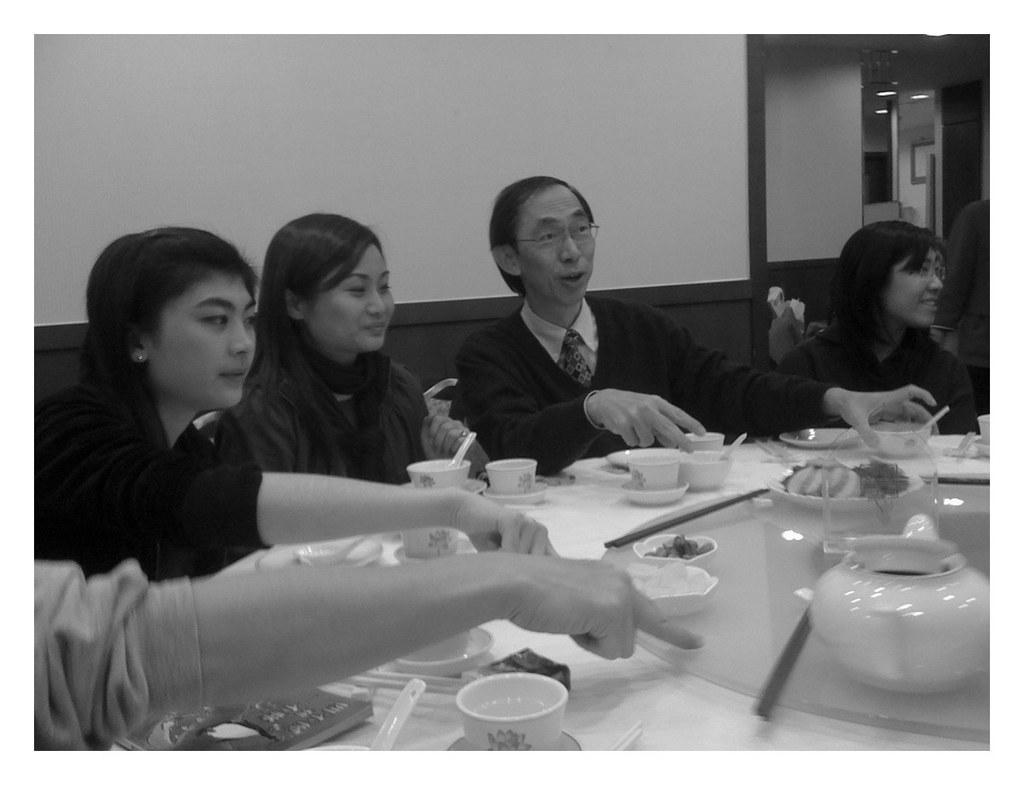Can you describe this image briefly? In this image there are five people sitting at the dining table and having their food. On the dining table there are cups and saucers, and bowls. In the background there is a wall with white color. 